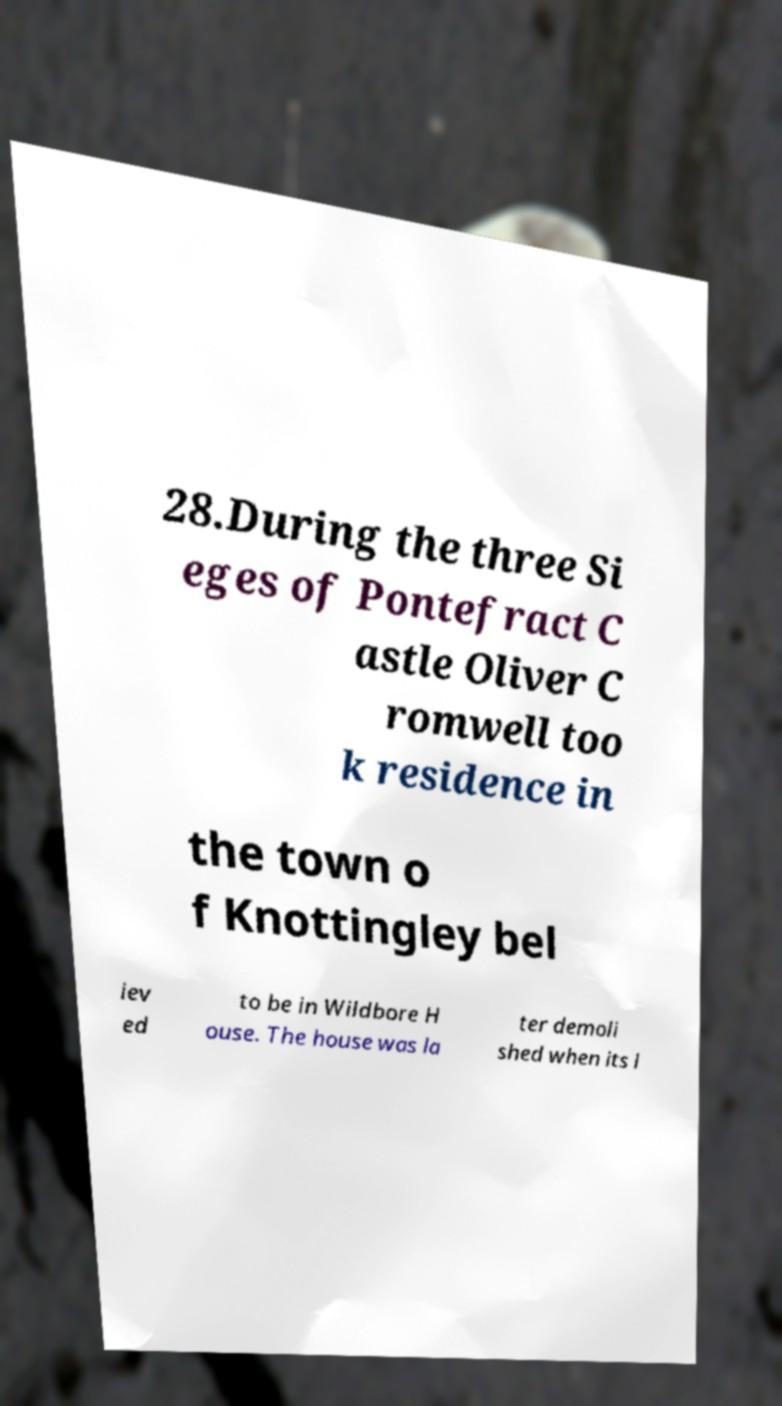Could you extract and type out the text from this image? 28.During the three Si eges of Pontefract C astle Oliver C romwell too k residence in the town o f Knottingley bel iev ed to be in Wildbore H ouse. The house was la ter demoli shed when its l 